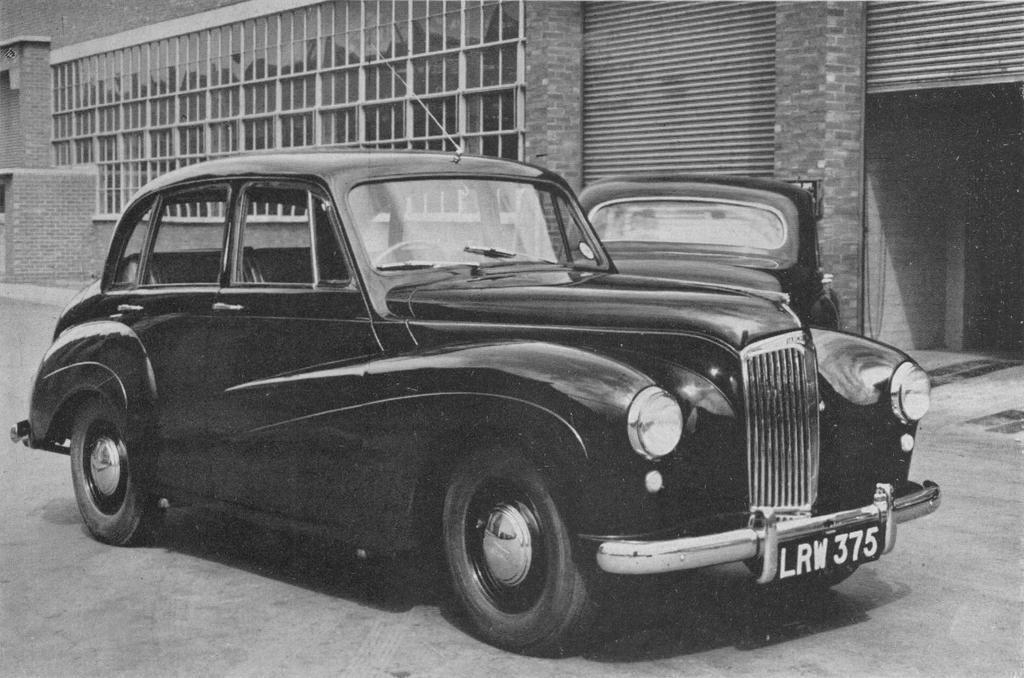Describe this image in one or two sentences. Here in this picture we can see two black colored cars present on the ground over there and beside that we can see shutters present over there and we can also see building present over there. 